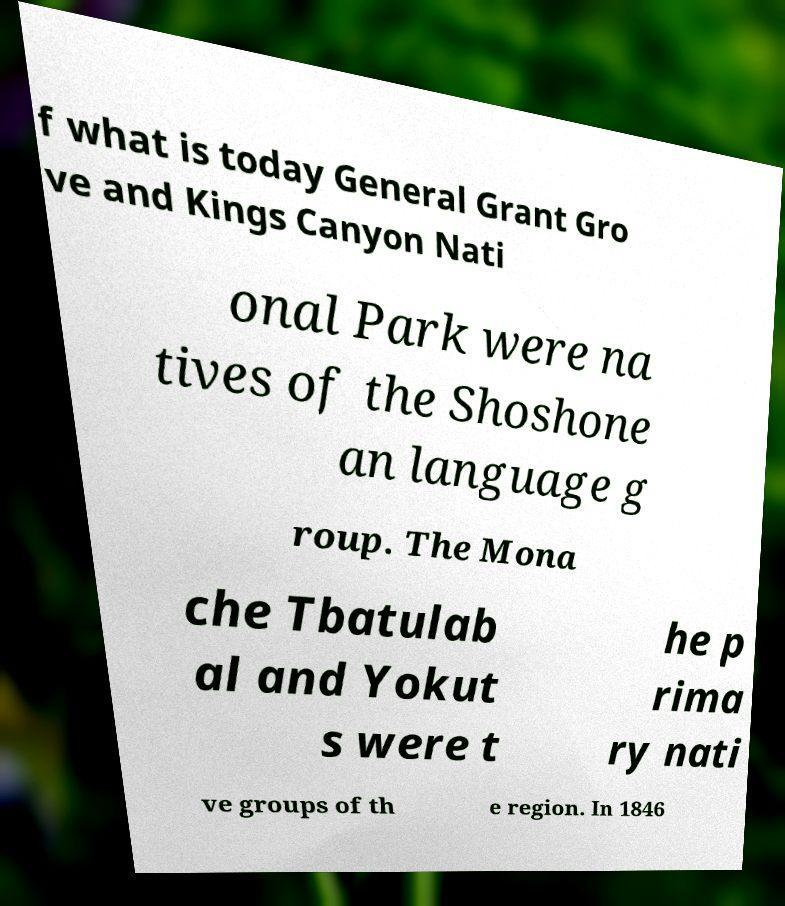Could you assist in decoding the text presented in this image and type it out clearly? f what is today General Grant Gro ve and Kings Canyon Nati onal Park were na tives of the Shoshone an language g roup. The Mona che Tbatulab al and Yokut s were t he p rima ry nati ve groups of th e region. In 1846 